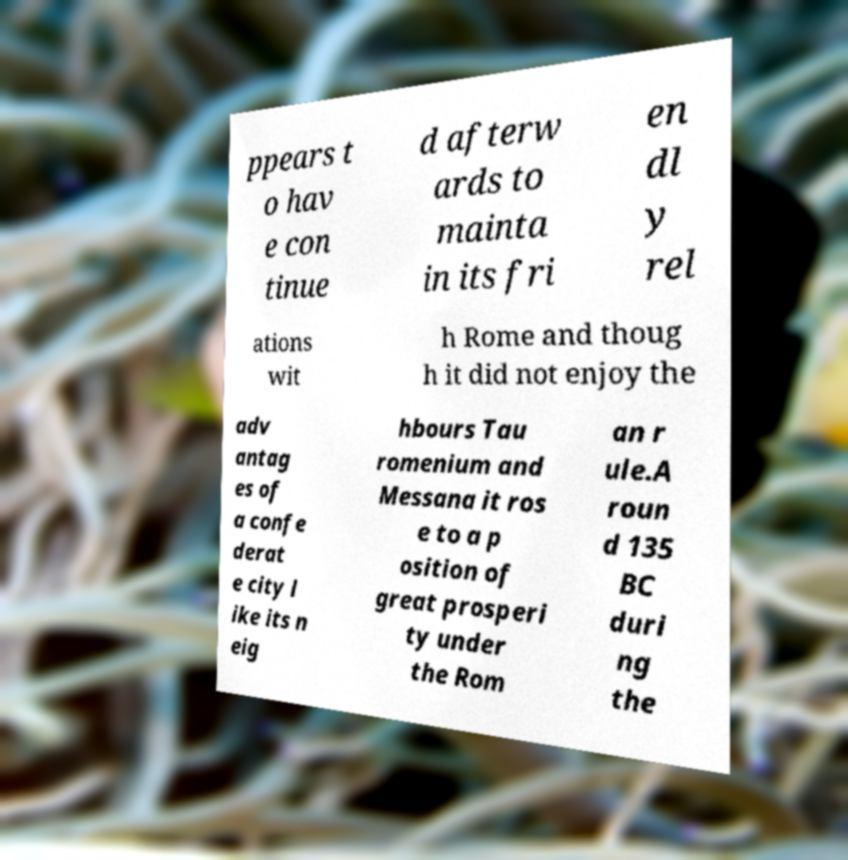Please read and relay the text visible in this image. What does it say? ppears t o hav e con tinue d afterw ards to mainta in its fri en dl y rel ations wit h Rome and thoug h it did not enjoy the adv antag es of a confe derat e city l ike its n eig hbours Tau romenium and Messana it ros e to a p osition of great prosperi ty under the Rom an r ule.A roun d 135 BC duri ng the 